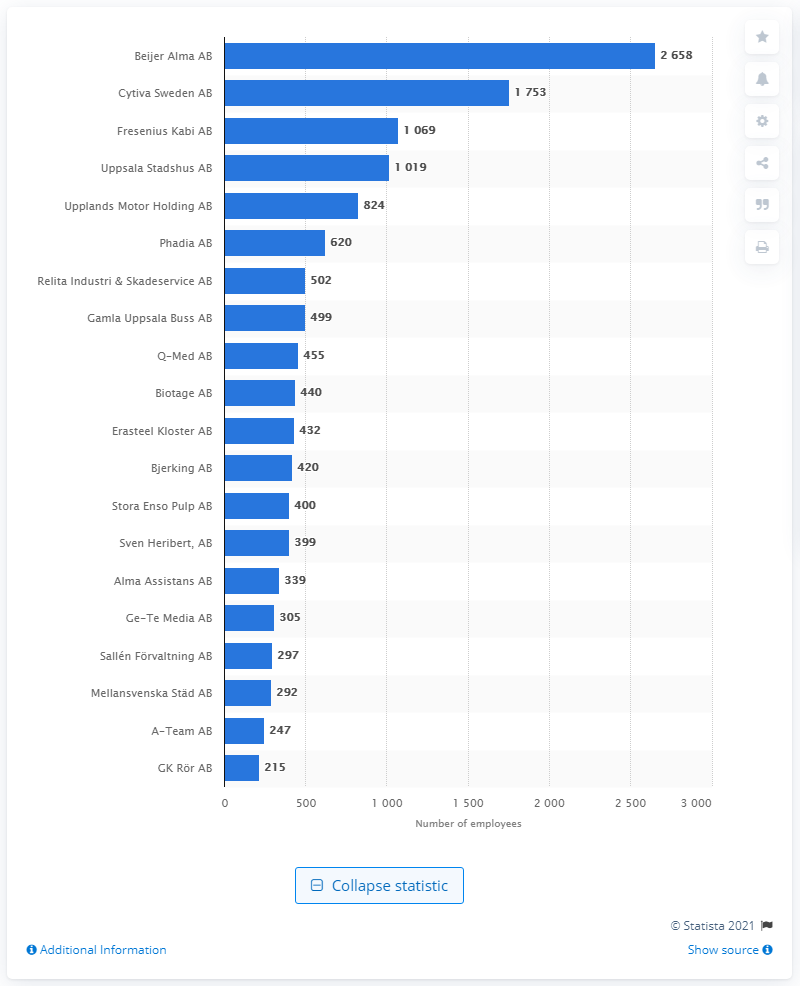Outline some significant characteristics in this image. As of February 2021, Beijer Alma AB was the largest company in Uppsala county. Cytiva Sweden AB was the second largest company in Uppsala county in 2021. 